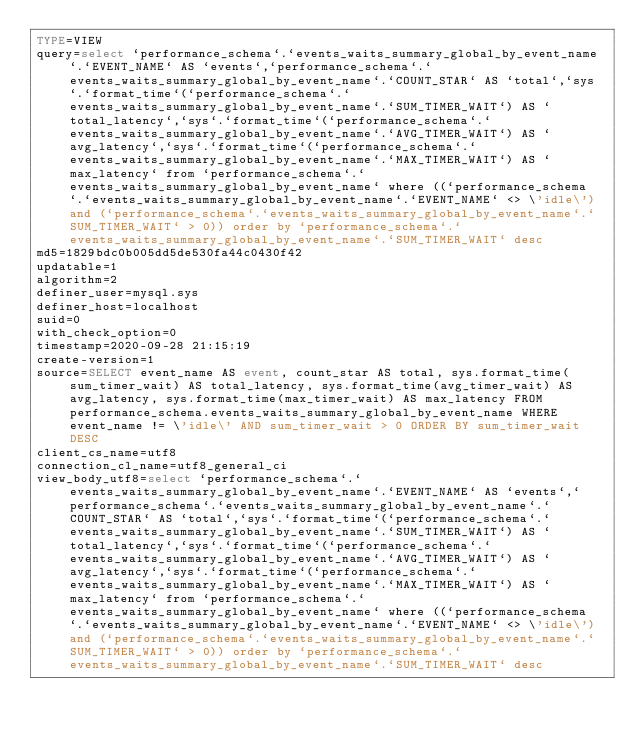Convert code to text. <code><loc_0><loc_0><loc_500><loc_500><_VisualBasic_>TYPE=VIEW
query=select `performance_schema`.`events_waits_summary_global_by_event_name`.`EVENT_NAME` AS `events`,`performance_schema`.`events_waits_summary_global_by_event_name`.`COUNT_STAR` AS `total`,`sys`.`format_time`(`performance_schema`.`events_waits_summary_global_by_event_name`.`SUM_TIMER_WAIT`) AS `total_latency`,`sys`.`format_time`(`performance_schema`.`events_waits_summary_global_by_event_name`.`AVG_TIMER_WAIT`) AS `avg_latency`,`sys`.`format_time`(`performance_schema`.`events_waits_summary_global_by_event_name`.`MAX_TIMER_WAIT`) AS `max_latency` from `performance_schema`.`events_waits_summary_global_by_event_name` where ((`performance_schema`.`events_waits_summary_global_by_event_name`.`EVENT_NAME` <> \'idle\') and (`performance_schema`.`events_waits_summary_global_by_event_name`.`SUM_TIMER_WAIT` > 0)) order by `performance_schema`.`events_waits_summary_global_by_event_name`.`SUM_TIMER_WAIT` desc
md5=1829bdc0b005dd5de530fa44c0430f42
updatable=1
algorithm=2
definer_user=mysql.sys
definer_host=localhost
suid=0
with_check_option=0
timestamp=2020-09-28 21:15:19
create-version=1
source=SELECT event_name AS event, count_star AS total, sys.format_time(sum_timer_wait) AS total_latency, sys.format_time(avg_timer_wait) AS avg_latency, sys.format_time(max_timer_wait) AS max_latency FROM performance_schema.events_waits_summary_global_by_event_name WHERE event_name != \'idle\' AND sum_timer_wait > 0 ORDER BY sum_timer_wait DESC
client_cs_name=utf8
connection_cl_name=utf8_general_ci
view_body_utf8=select `performance_schema`.`events_waits_summary_global_by_event_name`.`EVENT_NAME` AS `events`,`performance_schema`.`events_waits_summary_global_by_event_name`.`COUNT_STAR` AS `total`,`sys`.`format_time`(`performance_schema`.`events_waits_summary_global_by_event_name`.`SUM_TIMER_WAIT`) AS `total_latency`,`sys`.`format_time`(`performance_schema`.`events_waits_summary_global_by_event_name`.`AVG_TIMER_WAIT`) AS `avg_latency`,`sys`.`format_time`(`performance_schema`.`events_waits_summary_global_by_event_name`.`MAX_TIMER_WAIT`) AS `max_latency` from `performance_schema`.`events_waits_summary_global_by_event_name` where ((`performance_schema`.`events_waits_summary_global_by_event_name`.`EVENT_NAME` <> \'idle\') and (`performance_schema`.`events_waits_summary_global_by_event_name`.`SUM_TIMER_WAIT` > 0)) order by `performance_schema`.`events_waits_summary_global_by_event_name`.`SUM_TIMER_WAIT` desc
</code> 